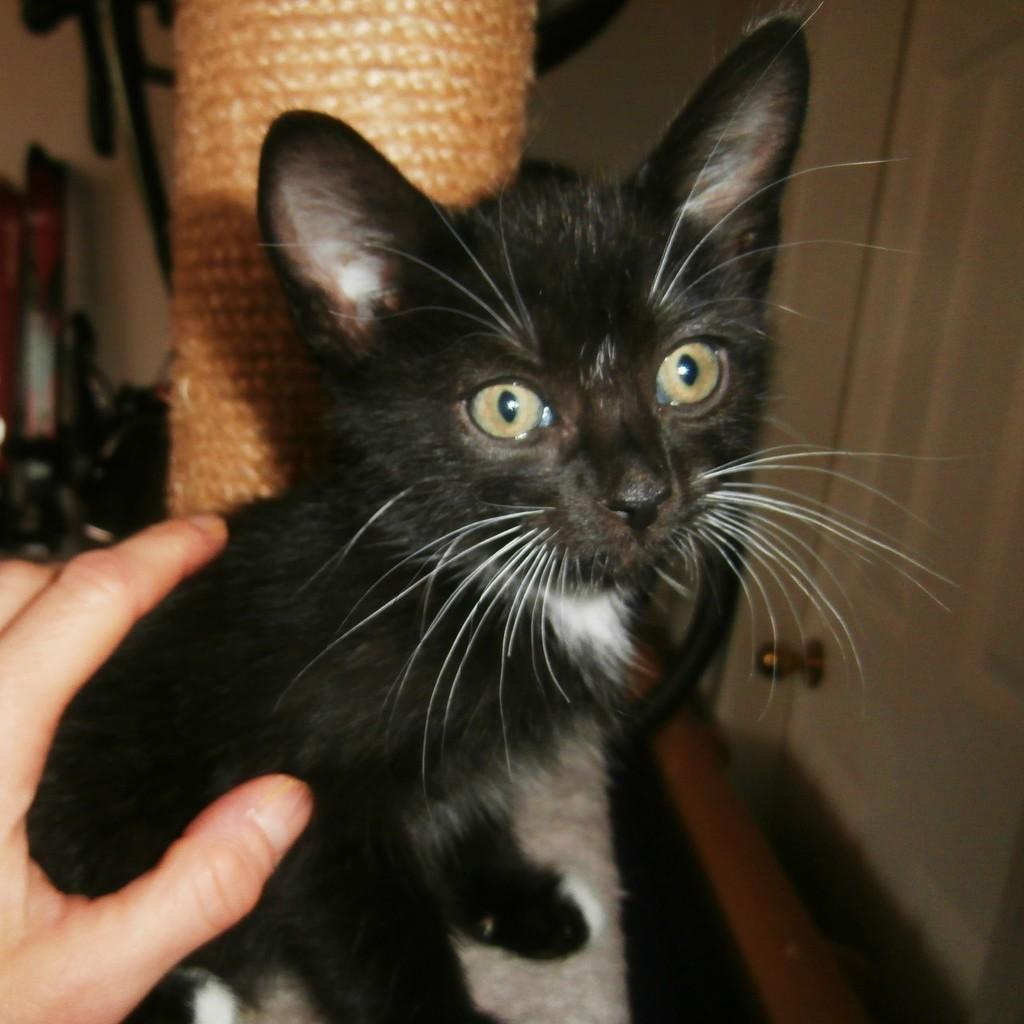Could you give a brief overview of what you see in this image? In the foreground I can see a cat and a person's hand. In the background I can see a pillar, wall, door and some objects. This image is taken may be in a room. 